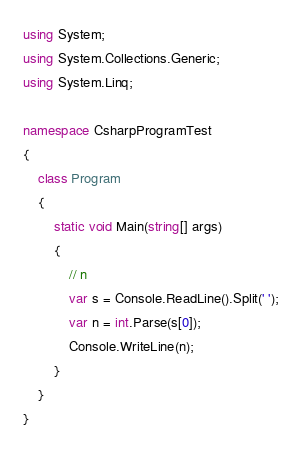<code> <loc_0><loc_0><loc_500><loc_500><_C#_>using System;
using System.Collections.Generic;
using System.Linq;

namespace CsharpProgramTest
{
    class Program
    {
        static void Main(string[] args)
        {
            // n
            var s = Console.ReadLine().Split(' ');
            var n = int.Parse(s[0]);
            Console.WriteLine(n);
        }
    }
}</code> 